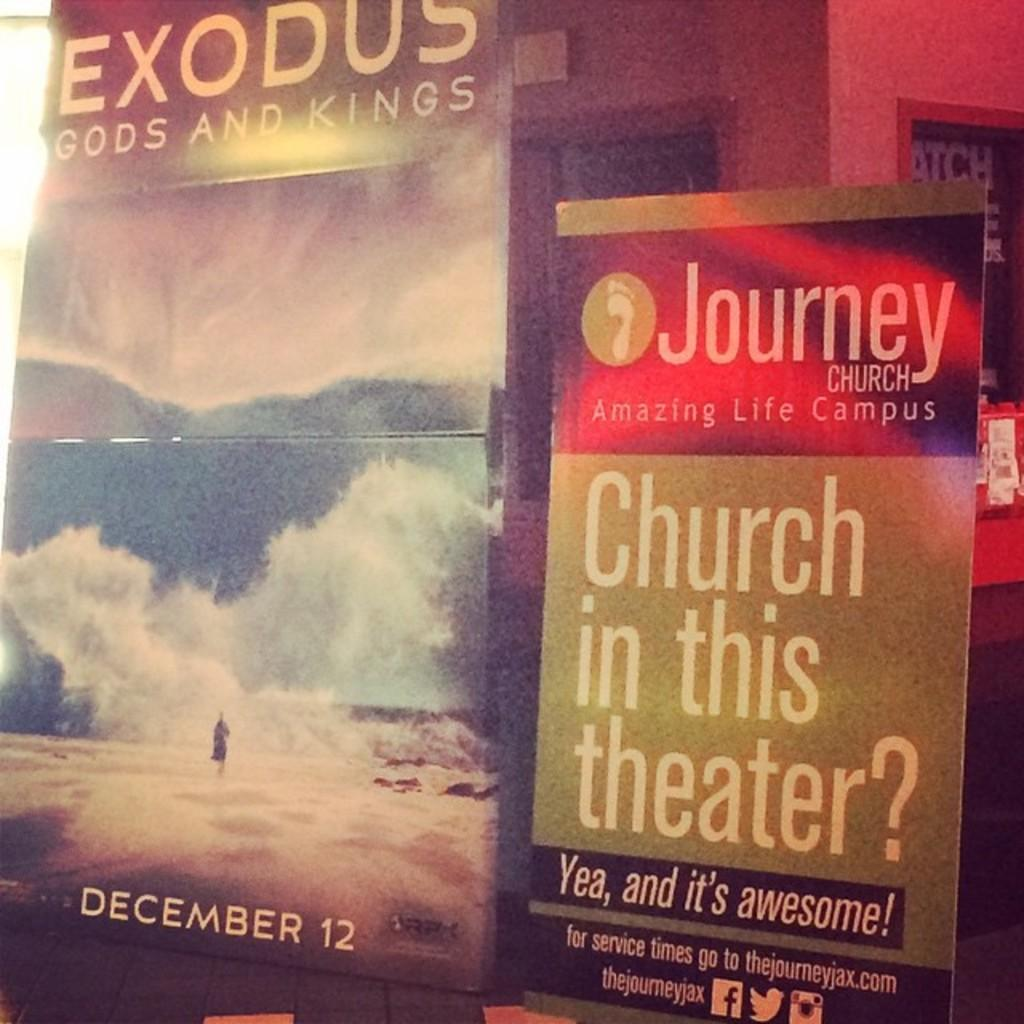<image>
Create a compact narrative representing the image presented. A poster for the film Exodus Gods And Kings with a book called Journey beside it. 